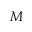<formula> <loc_0><loc_0><loc_500><loc_500>M</formula> 